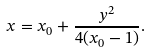Convert formula to latex. <formula><loc_0><loc_0><loc_500><loc_500>x = x _ { 0 } + \frac { y ^ { 2 } } { 4 ( x _ { 0 } - 1 ) } .</formula> 